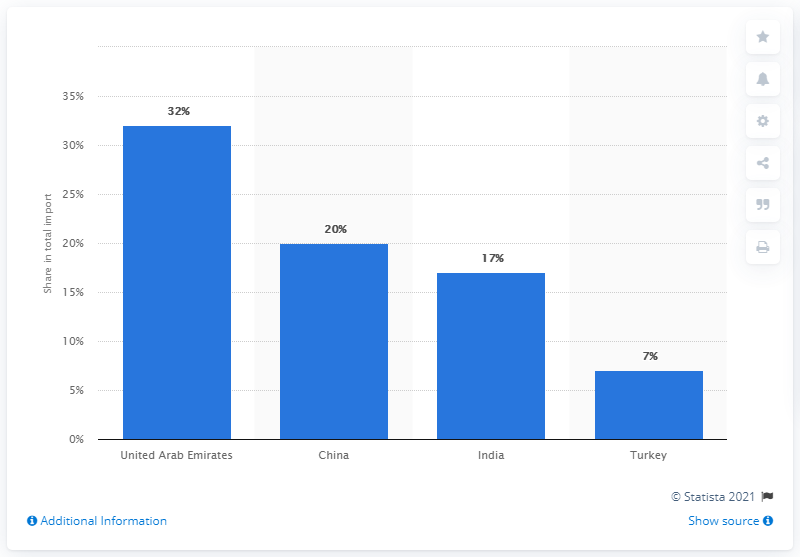Mention a couple of crucial points in this snapshot. In 2019, the United Arab Emirates was the most important import partner for Somalia. 